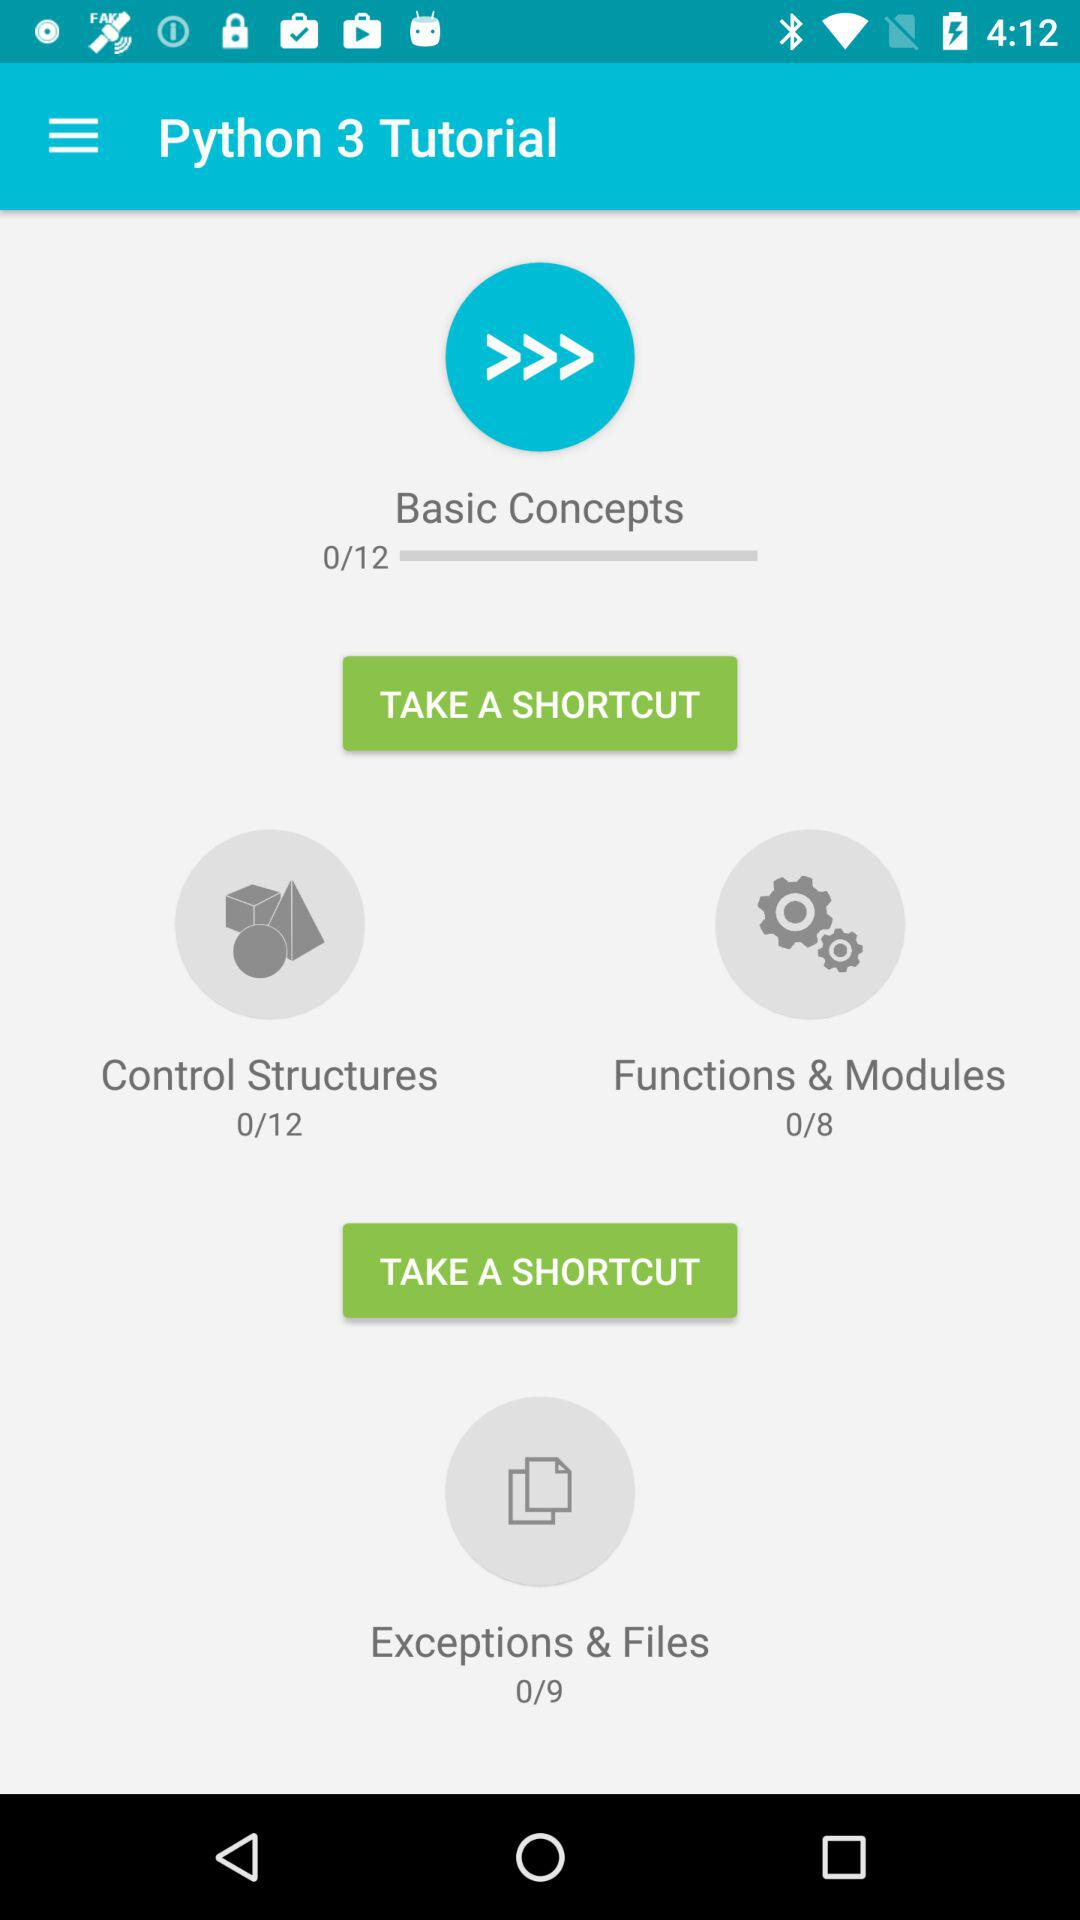Which module has eight chapters? The module that has eight chapters is "Functions & Modules". 